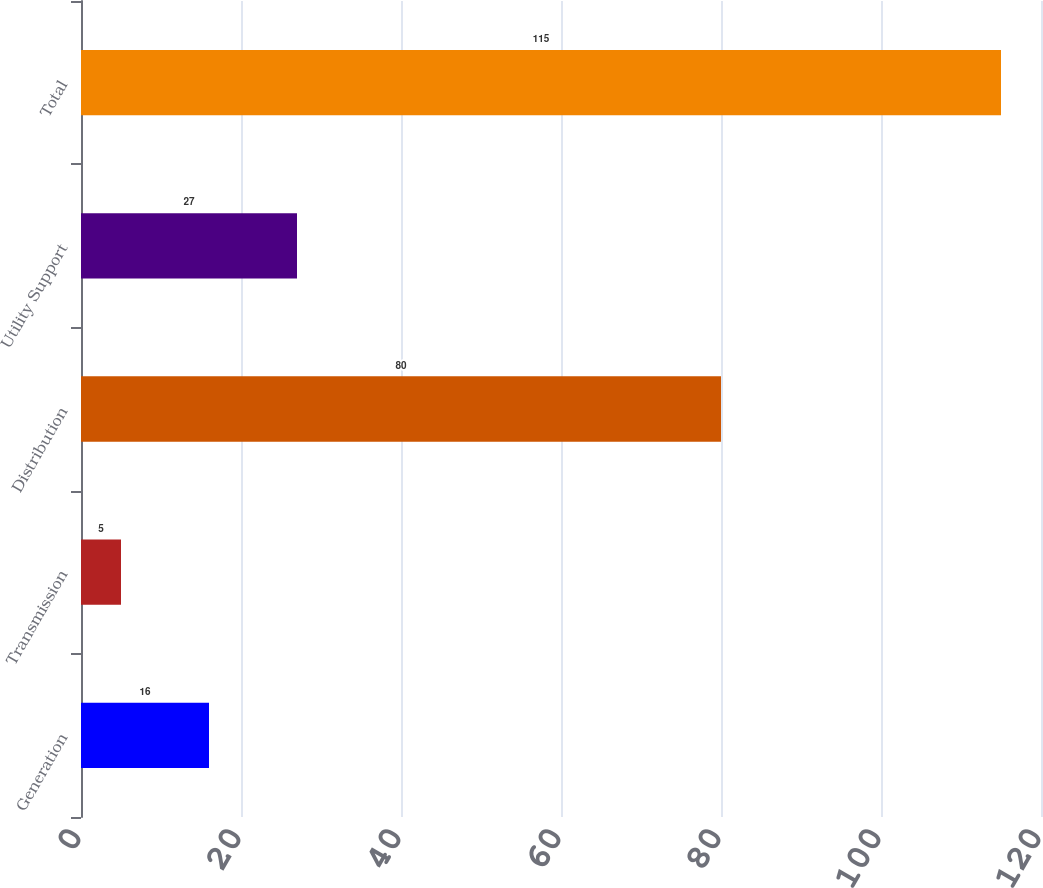Convert chart to OTSL. <chart><loc_0><loc_0><loc_500><loc_500><bar_chart><fcel>Generation<fcel>Transmission<fcel>Distribution<fcel>Utility Support<fcel>Total<nl><fcel>16<fcel>5<fcel>80<fcel>27<fcel>115<nl></chart> 